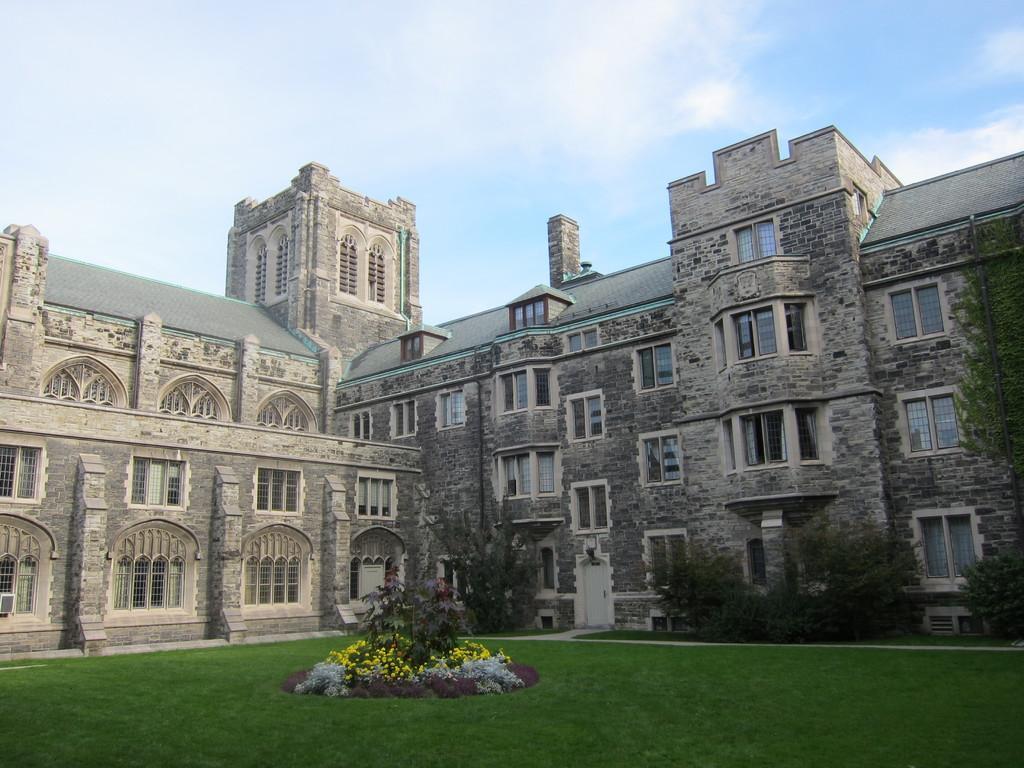How would you summarize this image in a sentence or two? In this image there is a building, in front of the building there are trees, flowers, plants and the surface of the grass. In the background there is the sky. 